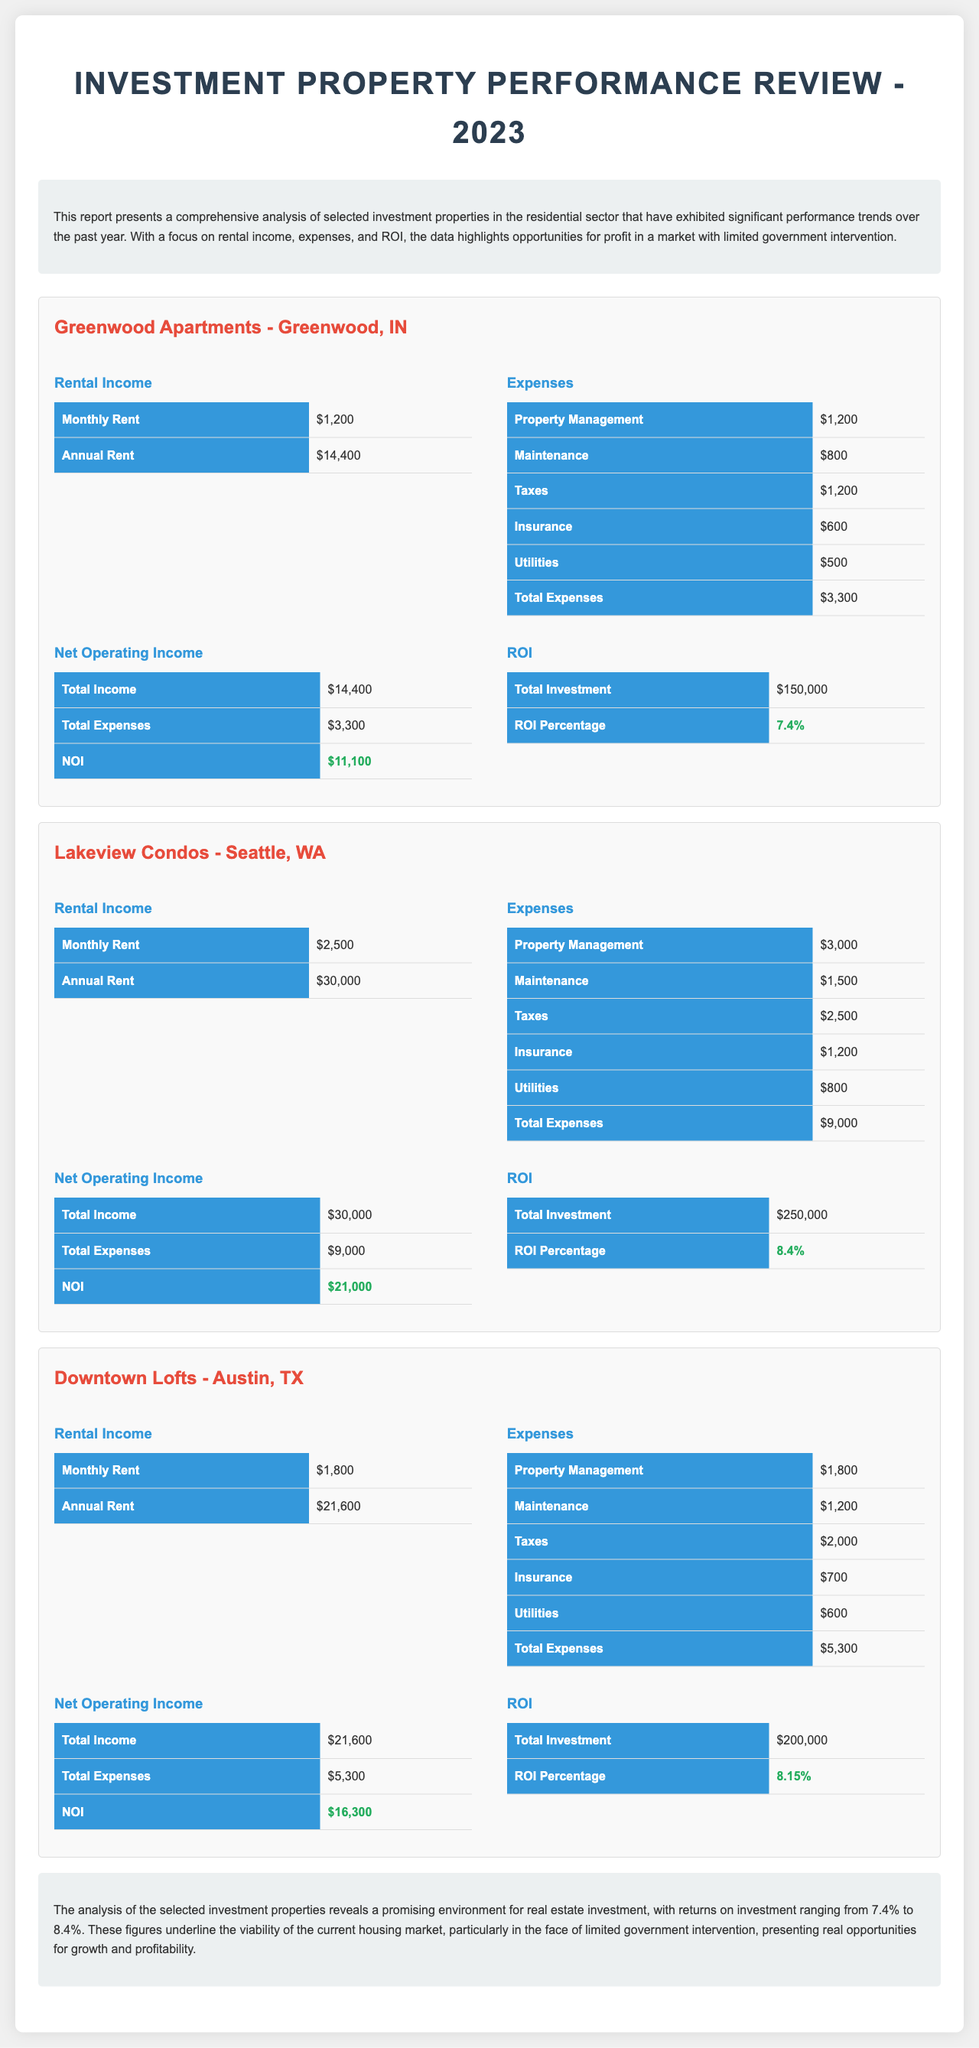What is the Annual Rent for Greenwood Apartments? The Annual Rent for Greenwood Apartments is detailed in the document as $14,400.
Answer: $14,400 What is the total expenses for Downtown Lofts? The total expenses for Downtown Lofts are explicitly stated in the document as $5,300.
Answer: $5,300 What is the Net Operating Income for Lakeview Condos? The Net Operating Income for Lakeview Condos is derived from the total income and total expenses, which is $30,000 - $9,000 = $21,000.
Answer: $21,000 Which property has the highest ROI percentage? The property with the highest ROI percentage is identified in the document as Lakeview Condos, with an ROI of 8.4%.
Answer: Lakeview Condos What is the total investment for Downtown Lofts? The total investment for Downtown Lofts is directly provided in the document as $200,000.
Answer: $200,000 What is the main focus of the report? The primary focus of the report is to analyze investment properties in terms of rental income, expenses, and ROI.
Answer: Rental income, expenses, and ROI What is the conclusion about the investment environment? The conclusion suggests that the investment environment is promising, highlighting viability amidst limited government intervention.
Answer: Promising environment What is the monthly rent for Lakeview Condos? The monthly rent for Lakeview Condos is specified in the document as $2,500.
Answer: $2,500 How much is spent on Insurance for Greenwood Apartments? The amount spent on Insurance for Greenwood Apartments is reported as $600 in the document.
Answer: $600 